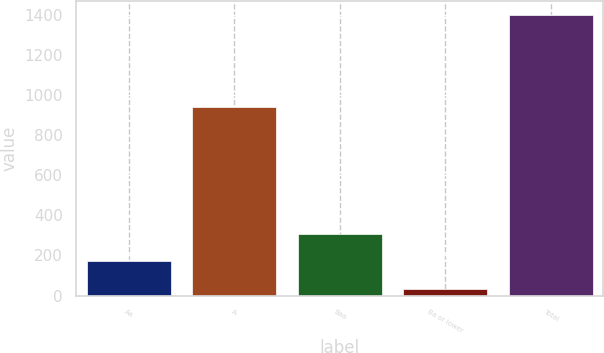Convert chart to OTSL. <chart><loc_0><loc_0><loc_500><loc_500><bar_chart><fcel>Aa<fcel>A<fcel>Baa<fcel>Ba or lower<fcel>Total<nl><fcel>170.4<fcel>941<fcel>306.8<fcel>34<fcel>1398<nl></chart> 